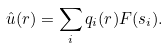Convert formula to latex. <formula><loc_0><loc_0><loc_500><loc_500>\hat { u } ( r ) = \sum _ { i } q _ { i } ( r ) F ( s _ { i } ) .</formula> 